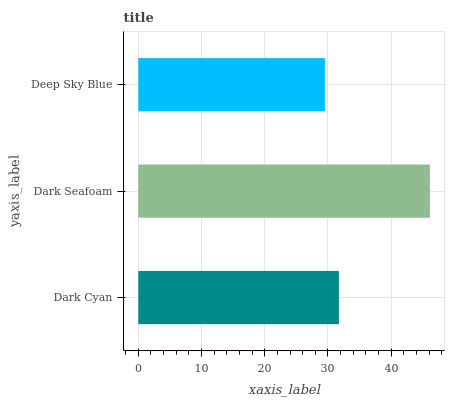Is Deep Sky Blue the minimum?
Answer yes or no. Yes. Is Dark Seafoam the maximum?
Answer yes or no. Yes. Is Dark Seafoam the minimum?
Answer yes or no. No. Is Deep Sky Blue the maximum?
Answer yes or no. No. Is Dark Seafoam greater than Deep Sky Blue?
Answer yes or no. Yes. Is Deep Sky Blue less than Dark Seafoam?
Answer yes or no. Yes. Is Deep Sky Blue greater than Dark Seafoam?
Answer yes or no. No. Is Dark Seafoam less than Deep Sky Blue?
Answer yes or no. No. Is Dark Cyan the high median?
Answer yes or no. Yes. Is Dark Cyan the low median?
Answer yes or no. Yes. Is Deep Sky Blue the high median?
Answer yes or no. No. Is Dark Seafoam the low median?
Answer yes or no. No. 